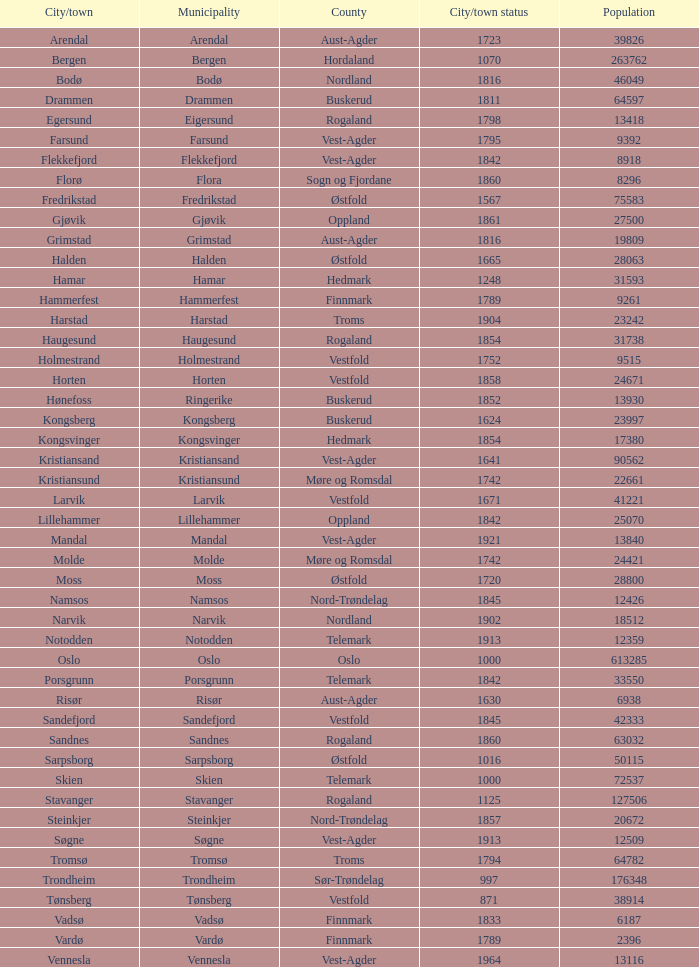In which county is the city/town of Halden located? Østfold. 